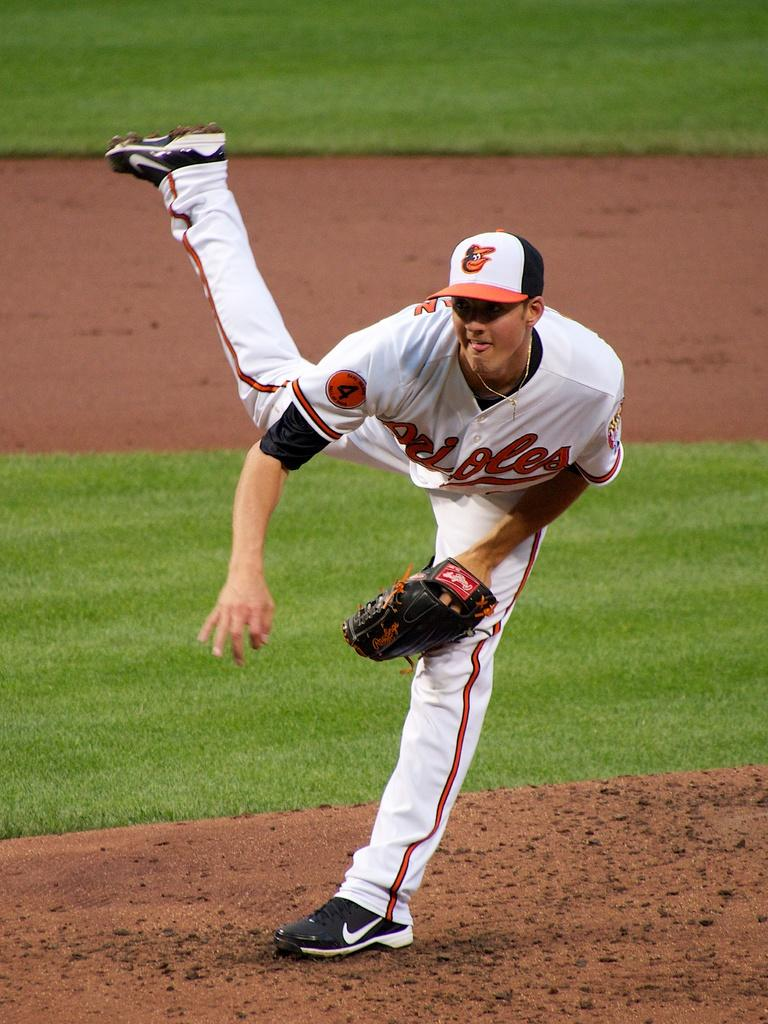<image>
Write a terse but informative summary of the picture. A baseball player with the number 4 on his uniform is pitching 